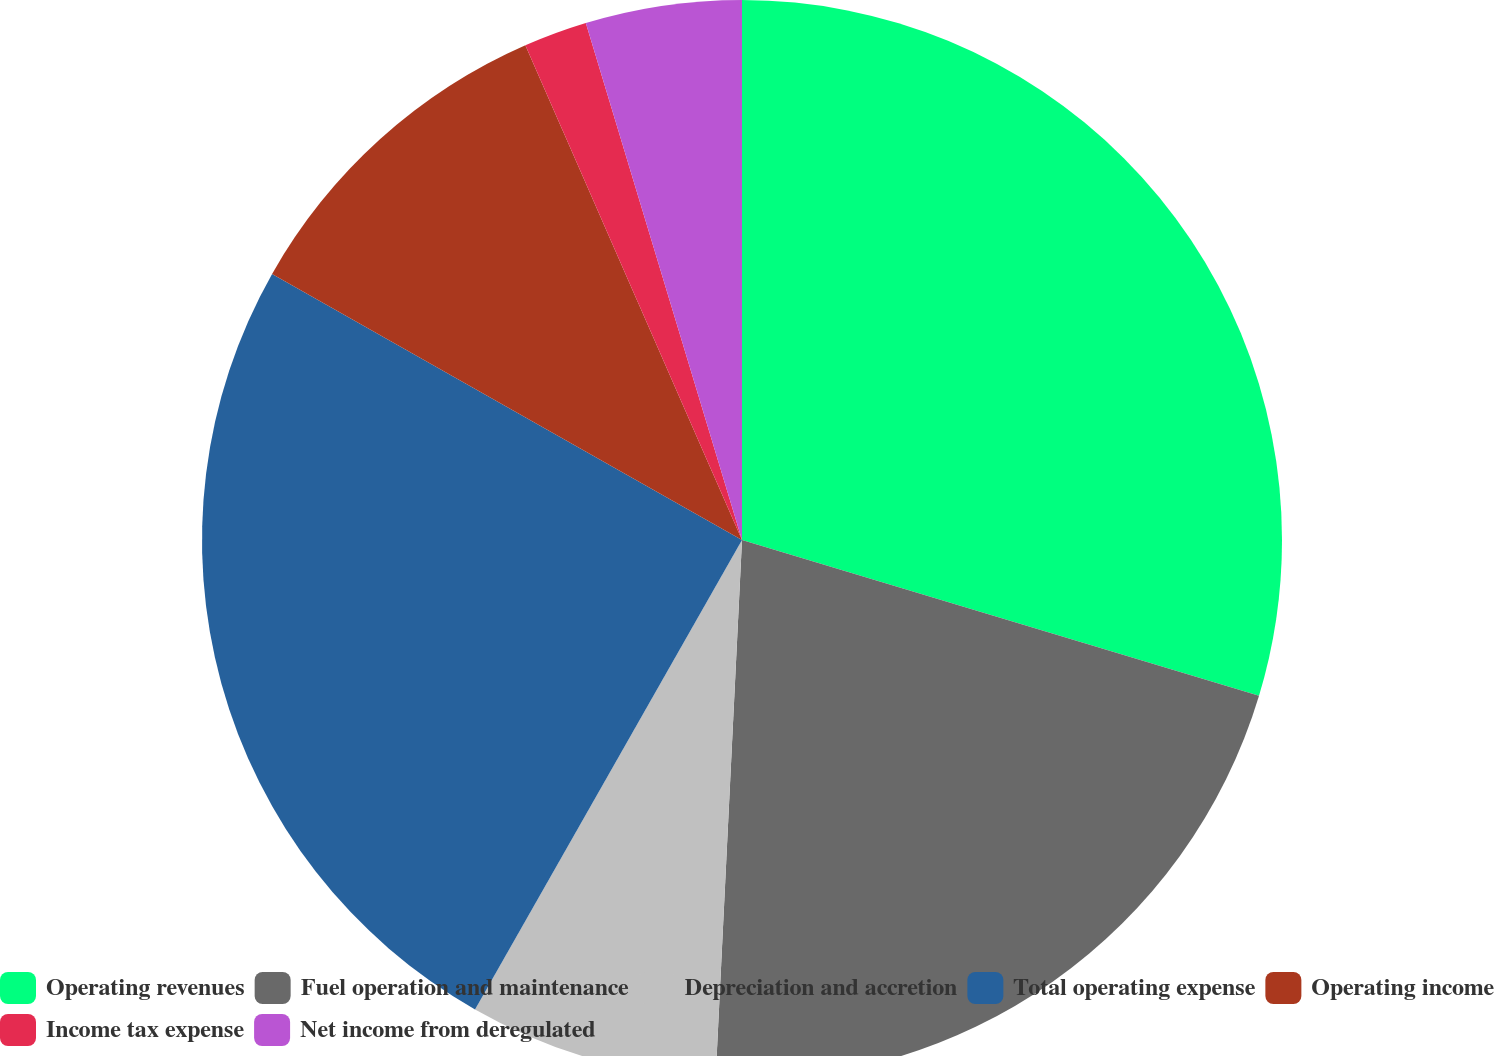<chart> <loc_0><loc_0><loc_500><loc_500><pie_chart><fcel>Operating revenues<fcel>Fuel operation and maintenance<fcel>Depreciation and accretion<fcel>Total operating expense<fcel>Operating income<fcel>Income tax expense<fcel>Net income from deregulated<nl><fcel>29.66%<fcel>21.12%<fcel>7.45%<fcel>24.97%<fcel>10.23%<fcel>1.9%<fcel>4.67%<nl></chart> 